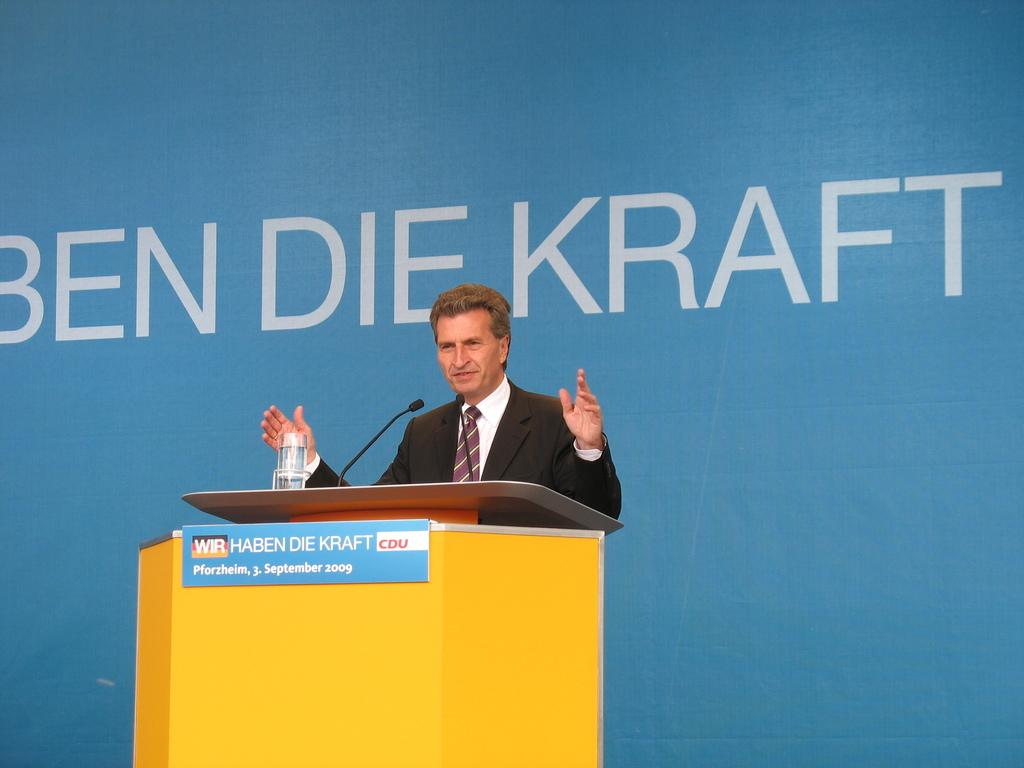What is the person in the image doing? There is a person at a desk in the image. What equipment does the person have? The person has mics. What is on the desk besides the person and mics? There is water on the desk and a glass on the desk. What can be seen in the background of the image? There is a screen in the background of the image. What type of canvas is the person using to record their voice in the image? There is no canvas present in the image, and the person is not using a canvas to record their voice. 